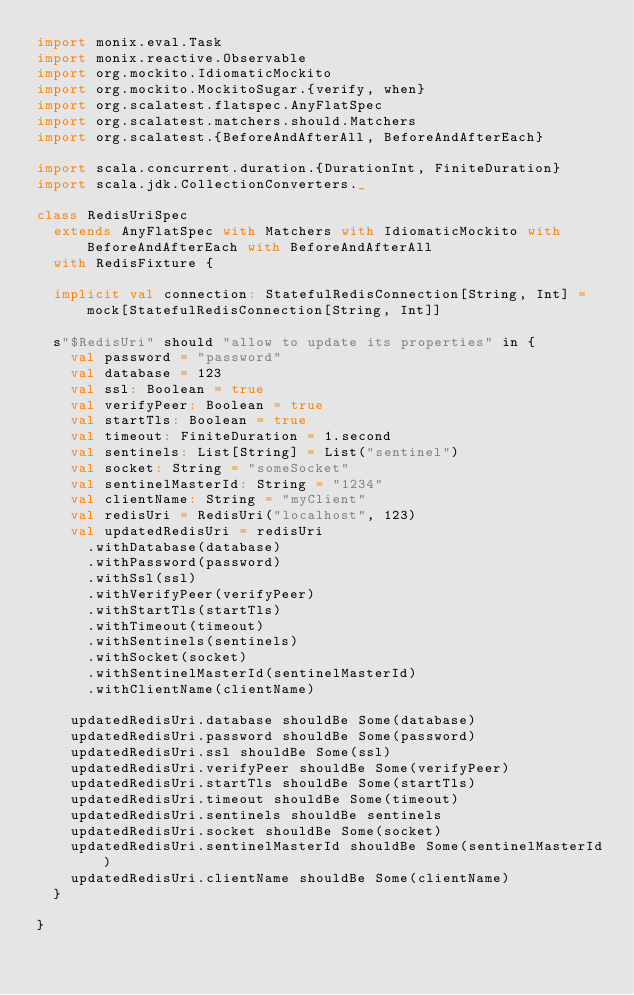Convert code to text. <code><loc_0><loc_0><loc_500><loc_500><_Scala_>import monix.eval.Task
import monix.reactive.Observable
import org.mockito.IdiomaticMockito
import org.mockito.MockitoSugar.{verify, when}
import org.scalatest.flatspec.AnyFlatSpec
import org.scalatest.matchers.should.Matchers
import org.scalatest.{BeforeAndAfterAll, BeforeAndAfterEach}

import scala.concurrent.duration.{DurationInt, FiniteDuration}
import scala.jdk.CollectionConverters._

class RedisUriSpec
  extends AnyFlatSpec with Matchers with IdiomaticMockito with BeforeAndAfterEach with BeforeAndAfterAll
  with RedisFixture {

  implicit val connection: StatefulRedisConnection[String, Int] = mock[StatefulRedisConnection[String, Int]]

  s"$RedisUri" should "allow to update its properties" in {
    val password = "password"
    val database = 123
    val ssl: Boolean = true
    val verifyPeer: Boolean = true
    val startTls: Boolean = true
    val timeout: FiniteDuration = 1.second
    val sentinels: List[String] = List("sentinel")
    val socket: String = "someSocket"
    val sentinelMasterId: String = "1234"
    val clientName: String = "myClient"
    val redisUri = RedisUri("localhost", 123)
    val updatedRedisUri = redisUri
      .withDatabase(database)
      .withPassword(password)
      .withSsl(ssl)
      .withVerifyPeer(verifyPeer)
      .withStartTls(startTls)
      .withTimeout(timeout)
      .withSentinels(sentinels)
      .withSocket(socket)
      .withSentinelMasterId(sentinelMasterId)
      .withClientName(clientName)

    updatedRedisUri.database shouldBe Some(database)
    updatedRedisUri.password shouldBe Some(password)
    updatedRedisUri.ssl shouldBe Some(ssl)
    updatedRedisUri.verifyPeer shouldBe Some(verifyPeer)
    updatedRedisUri.startTls shouldBe Some(startTls)
    updatedRedisUri.timeout shouldBe Some(timeout)
    updatedRedisUri.sentinels shouldBe sentinels
    updatedRedisUri.socket shouldBe Some(socket)
    updatedRedisUri.sentinelMasterId shouldBe Some(sentinelMasterId)
    updatedRedisUri.clientName shouldBe Some(clientName)
  }

}
</code> 